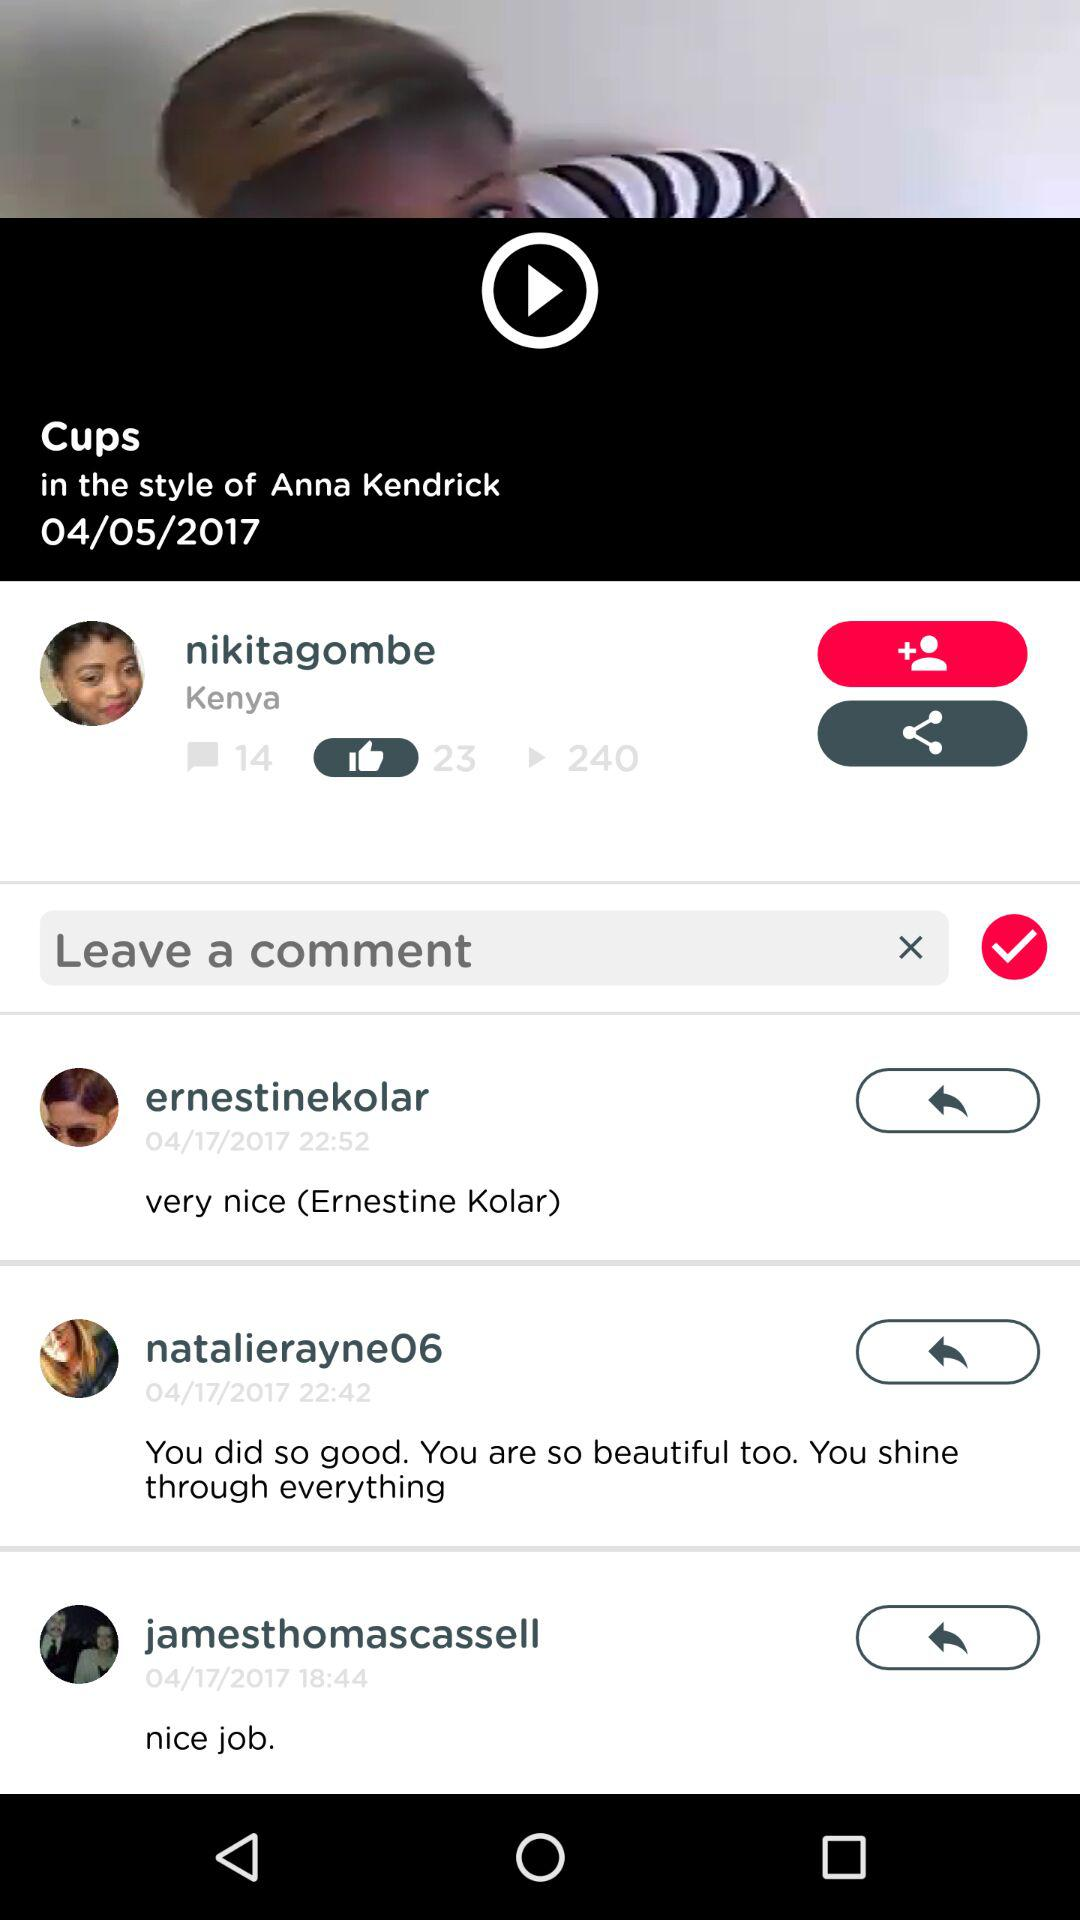How many likes are on "nikitagombe" profile? There are 23 likes on "nikitagombe" profile. 